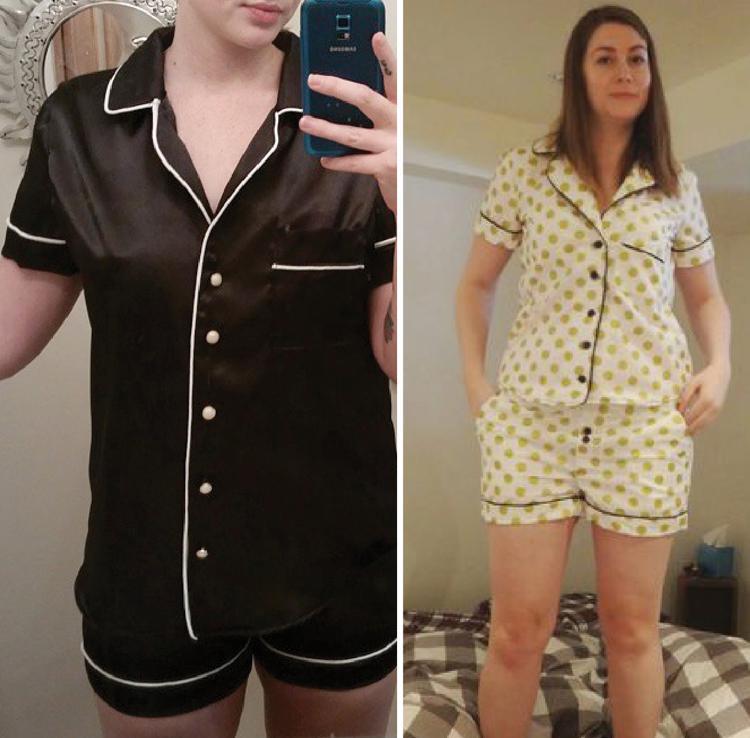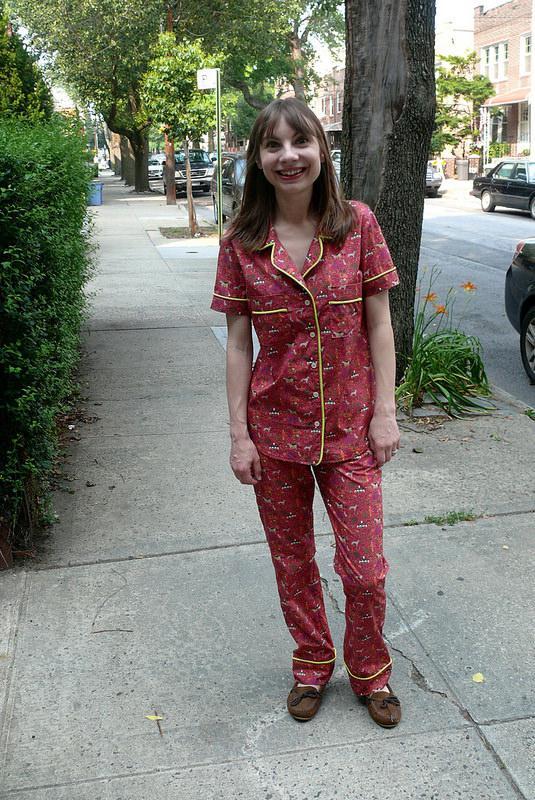The first image is the image on the left, the second image is the image on the right. Considering the images on both sides, is "The right image contains a human wearing a red pajama top while standing outside on a sidewalk." valid? Answer yes or no. Yes. The first image is the image on the left, the second image is the image on the right. For the images shown, is this caption "The lefthand image shows a pair of pajama-clad models in side-by-side views." true? Answer yes or no. Yes. 